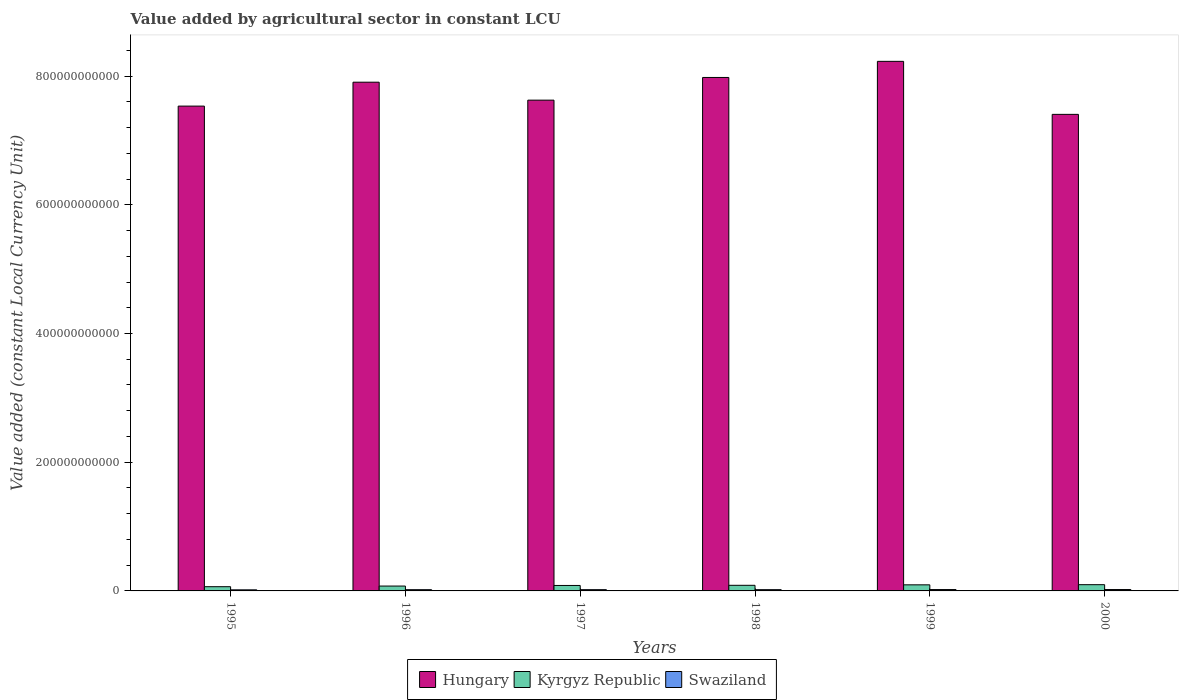How many different coloured bars are there?
Give a very brief answer. 3. How many groups of bars are there?
Ensure brevity in your answer.  6. Are the number of bars per tick equal to the number of legend labels?
Your answer should be compact. Yes. Are the number of bars on each tick of the X-axis equal?
Give a very brief answer. Yes. How many bars are there on the 6th tick from the left?
Your response must be concise. 3. What is the label of the 3rd group of bars from the left?
Offer a very short reply. 1997. In how many cases, is the number of bars for a given year not equal to the number of legend labels?
Your answer should be very brief. 0. What is the value added by agricultural sector in Swaziland in 1997?
Offer a very short reply. 1.96e+09. Across all years, what is the maximum value added by agricultural sector in Hungary?
Provide a succinct answer. 8.23e+11. Across all years, what is the minimum value added by agricultural sector in Hungary?
Keep it short and to the point. 7.41e+11. In which year was the value added by agricultural sector in Hungary minimum?
Offer a very short reply. 2000. What is the total value added by agricultural sector in Swaziland in the graph?
Your response must be concise. 1.18e+1. What is the difference between the value added by agricultural sector in Hungary in 1995 and that in 1998?
Offer a very short reply. -4.45e+1. What is the difference between the value added by agricultural sector in Kyrgyz Republic in 1997 and the value added by agricultural sector in Hungary in 1995?
Provide a succinct answer. -7.45e+11. What is the average value added by agricultural sector in Swaziland per year?
Ensure brevity in your answer.  1.97e+09. In the year 1997, what is the difference between the value added by agricultural sector in Kyrgyz Republic and value added by agricultural sector in Swaziland?
Provide a succinct answer. 6.53e+09. What is the ratio of the value added by agricultural sector in Swaziland in 1995 to that in 1997?
Offer a very short reply. 0.86. Is the value added by agricultural sector in Swaziland in 1995 less than that in 1996?
Provide a short and direct response. Yes. Is the difference between the value added by agricultural sector in Kyrgyz Republic in 1995 and 1996 greater than the difference between the value added by agricultural sector in Swaziland in 1995 and 1996?
Provide a succinct answer. No. What is the difference between the highest and the second highest value added by agricultural sector in Kyrgyz Republic?
Provide a short and direct response. 2.53e+08. What is the difference between the highest and the lowest value added by agricultural sector in Kyrgyz Republic?
Give a very brief answer. 3.14e+09. Is the sum of the value added by agricultural sector in Hungary in 1996 and 1998 greater than the maximum value added by agricultural sector in Swaziland across all years?
Your answer should be compact. Yes. What does the 1st bar from the left in 1999 represents?
Make the answer very short. Hungary. What does the 3rd bar from the right in 1999 represents?
Keep it short and to the point. Hungary. Is it the case that in every year, the sum of the value added by agricultural sector in Hungary and value added by agricultural sector in Swaziland is greater than the value added by agricultural sector in Kyrgyz Republic?
Keep it short and to the point. Yes. How many bars are there?
Ensure brevity in your answer.  18. How many years are there in the graph?
Your answer should be compact. 6. What is the difference between two consecutive major ticks on the Y-axis?
Give a very brief answer. 2.00e+11. Does the graph contain grids?
Provide a succinct answer. No. Where does the legend appear in the graph?
Provide a succinct answer. Bottom center. How are the legend labels stacked?
Give a very brief answer. Horizontal. What is the title of the graph?
Provide a short and direct response. Value added by agricultural sector in constant LCU. What is the label or title of the Y-axis?
Make the answer very short. Value added (constant Local Currency Unit). What is the Value added (constant Local Currency Unit) of Hungary in 1995?
Your response must be concise. 7.53e+11. What is the Value added (constant Local Currency Unit) of Kyrgyz Republic in 1995?
Ensure brevity in your answer.  6.57e+09. What is the Value added (constant Local Currency Unit) in Swaziland in 1995?
Offer a terse response. 1.69e+09. What is the Value added (constant Local Currency Unit) in Hungary in 1996?
Keep it short and to the point. 7.91e+11. What is the Value added (constant Local Currency Unit) in Kyrgyz Republic in 1996?
Your answer should be compact. 7.57e+09. What is the Value added (constant Local Currency Unit) of Swaziland in 1996?
Provide a succinct answer. 1.93e+09. What is the Value added (constant Local Currency Unit) of Hungary in 1997?
Ensure brevity in your answer.  7.63e+11. What is the Value added (constant Local Currency Unit) in Kyrgyz Republic in 1997?
Your answer should be very brief. 8.49e+09. What is the Value added (constant Local Currency Unit) of Swaziland in 1997?
Ensure brevity in your answer.  1.96e+09. What is the Value added (constant Local Currency Unit) of Hungary in 1998?
Provide a short and direct response. 7.98e+11. What is the Value added (constant Local Currency Unit) of Kyrgyz Republic in 1998?
Provide a succinct answer. 8.74e+09. What is the Value added (constant Local Currency Unit) of Swaziland in 1998?
Offer a very short reply. 1.96e+09. What is the Value added (constant Local Currency Unit) in Hungary in 1999?
Your answer should be very brief. 8.23e+11. What is the Value added (constant Local Currency Unit) in Kyrgyz Republic in 1999?
Keep it short and to the point. 9.45e+09. What is the Value added (constant Local Currency Unit) of Swaziland in 1999?
Keep it short and to the point. 2.13e+09. What is the Value added (constant Local Currency Unit) in Hungary in 2000?
Your response must be concise. 7.41e+11. What is the Value added (constant Local Currency Unit) of Kyrgyz Republic in 2000?
Provide a short and direct response. 9.71e+09. What is the Value added (constant Local Currency Unit) of Swaziland in 2000?
Keep it short and to the point. 2.15e+09. Across all years, what is the maximum Value added (constant Local Currency Unit) in Hungary?
Ensure brevity in your answer.  8.23e+11. Across all years, what is the maximum Value added (constant Local Currency Unit) of Kyrgyz Republic?
Make the answer very short. 9.71e+09. Across all years, what is the maximum Value added (constant Local Currency Unit) in Swaziland?
Offer a terse response. 2.15e+09. Across all years, what is the minimum Value added (constant Local Currency Unit) in Hungary?
Your response must be concise. 7.41e+11. Across all years, what is the minimum Value added (constant Local Currency Unit) of Kyrgyz Republic?
Your response must be concise. 6.57e+09. Across all years, what is the minimum Value added (constant Local Currency Unit) of Swaziland?
Ensure brevity in your answer.  1.69e+09. What is the total Value added (constant Local Currency Unit) in Hungary in the graph?
Provide a short and direct response. 4.67e+12. What is the total Value added (constant Local Currency Unit) of Kyrgyz Republic in the graph?
Your response must be concise. 5.05e+1. What is the total Value added (constant Local Currency Unit) of Swaziland in the graph?
Offer a terse response. 1.18e+1. What is the difference between the Value added (constant Local Currency Unit) in Hungary in 1995 and that in 1996?
Offer a very short reply. -3.72e+1. What is the difference between the Value added (constant Local Currency Unit) in Kyrgyz Republic in 1995 and that in 1996?
Your response must be concise. -9.98e+08. What is the difference between the Value added (constant Local Currency Unit) of Swaziland in 1995 and that in 1996?
Make the answer very short. -2.33e+08. What is the difference between the Value added (constant Local Currency Unit) in Hungary in 1995 and that in 1997?
Ensure brevity in your answer.  -9.25e+09. What is the difference between the Value added (constant Local Currency Unit) in Kyrgyz Republic in 1995 and that in 1997?
Make the answer very short. -1.93e+09. What is the difference between the Value added (constant Local Currency Unit) in Swaziland in 1995 and that in 1997?
Your answer should be compact. -2.69e+08. What is the difference between the Value added (constant Local Currency Unit) in Hungary in 1995 and that in 1998?
Keep it short and to the point. -4.45e+1. What is the difference between the Value added (constant Local Currency Unit) of Kyrgyz Republic in 1995 and that in 1998?
Give a very brief answer. -2.17e+09. What is the difference between the Value added (constant Local Currency Unit) of Swaziland in 1995 and that in 1998?
Offer a very short reply. -2.66e+08. What is the difference between the Value added (constant Local Currency Unit) of Hungary in 1995 and that in 1999?
Your response must be concise. -6.95e+1. What is the difference between the Value added (constant Local Currency Unit) of Kyrgyz Republic in 1995 and that in 1999?
Ensure brevity in your answer.  -2.88e+09. What is the difference between the Value added (constant Local Currency Unit) of Swaziland in 1995 and that in 1999?
Your answer should be compact. -4.38e+08. What is the difference between the Value added (constant Local Currency Unit) of Hungary in 1995 and that in 2000?
Your answer should be very brief. 1.28e+1. What is the difference between the Value added (constant Local Currency Unit) of Kyrgyz Republic in 1995 and that in 2000?
Ensure brevity in your answer.  -3.14e+09. What is the difference between the Value added (constant Local Currency Unit) of Swaziland in 1995 and that in 2000?
Your response must be concise. -4.54e+08. What is the difference between the Value added (constant Local Currency Unit) in Hungary in 1996 and that in 1997?
Your response must be concise. 2.79e+1. What is the difference between the Value added (constant Local Currency Unit) in Kyrgyz Republic in 1996 and that in 1997?
Your response must be concise. -9.27e+08. What is the difference between the Value added (constant Local Currency Unit) of Swaziland in 1996 and that in 1997?
Offer a very short reply. -3.54e+07. What is the difference between the Value added (constant Local Currency Unit) of Hungary in 1996 and that in 1998?
Your answer should be very brief. -7.34e+09. What is the difference between the Value added (constant Local Currency Unit) of Kyrgyz Republic in 1996 and that in 1998?
Provide a short and direct response. -1.17e+09. What is the difference between the Value added (constant Local Currency Unit) in Swaziland in 1996 and that in 1998?
Your answer should be compact. -3.24e+07. What is the difference between the Value added (constant Local Currency Unit) of Hungary in 1996 and that in 1999?
Give a very brief answer. -3.24e+1. What is the difference between the Value added (constant Local Currency Unit) of Kyrgyz Republic in 1996 and that in 1999?
Offer a terse response. -1.89e+09. What is the difference between the Value added (constant Local Currency Unit) of Swaziland in 1996 and that in 1999?
Your response must be concise. -2.04e+08. What is the difference between the Value added (constant Local Currency Unit) in Hungary in 1996 and that in 2000?
Give a very brief answer. 5.00e+1. What is the difference between the Value added (constant Local Currency Unit) of Kyrgyz Republic in 1996 and that in 2000?
Ensure brevity in your answer.  -2.14e+09. What is the difference between the Value added (constant Local Currency Unit) in Swaziland in 1996 and that in 2000?
Offer a terse response. -2.21e+08. What is the difference between the Value added (constant Local Currency Unit) of Hungary in 1997 and that in 1998?
Give a very brief answer. -3.53e+1. What is the difference between the Value added (constant Local Currency Unit) in Kyrgyz Republic in 1997 and that in 1998?
Provide a short and direct response. -2.42e+08. What is the difference between the Value added (constant Local Currency Unit) in Swaziland in 1997 and that in 1998?
Offer a terse response. 3.04e+06. What is the difference between the Value added (constant Local Currency Unit) of Hungary in 1997 and that in 1999?
Offer a very short reply. -6.03e+1. What is the difference between the Value added (constant Local Currency Unit) in Kyrgyz Republic in 1997 and that in 1999?
Offer a very short reply. -9.60e+08. What is the difference between the Value added (constant Local Currency Unit) of Swaziland in 1997 and that in 1999?
Ensure brevity in your answer.  -1.69e+08. What is the difference between the Value added (constant Local Currency Unit) of Hungary in 1997 and that in 2000?
Provide a succinct answer. 2.21e+1. What is the difference between the Value added (constant Local Currency Unit) of Kyrgyz Republic in 1997 and that in 2000?
Your answer should be very brief. -1.21e+09. What is the difference between the Value added (constant Local Currency Unit) of Swaziland in 1997 and that in 2000?
Offer a terse response. -1.85e+08. What is the difference between the Value added (constant Local Currency Unit) in Hungary in 1998 and that in 1999?
Keep it short and to the point. -2.50e+1. What is the difference between the Value added (constant Local Currency Unit) in Kyrgyz Republic in 1998 and that in 1999?
Make the answer very short. -7.17e+08. What is the difference between the Value added (constant Local Currency Unit) in Swaziland in 1998 and that in 1999?
Give a very brief answer. -1.72e+08. What is the difference between the Value added (constant Local Currency Unit) of Hungary in 1998 and that in 2000?
Ensure brevity in your answer.  5.74e+1. What is the difference between the Value added (constant Local Currency Unit) in Kyrgyz Republic in 1998 and that in 2000?
Provide a succinct answer. -9.71e+08. What is the difference between the Value added (constant Local Currency Unit) of Swaziland in 1998 and that in 2000?
Offer a terse response. -1.89e+08. What is the difference between the Value added (constant Local Currency Unit) of Hungary in 1999 and that in 2000?
Your response must be concise. 8.24e+1. What is the difference between the Value added (constant Local Currency Unit) in Kyrgyz Republic in 1999 and that in 2000?
Offer a terse response. -2.53e+08. What is the difference between the Value added (constant Local Currency Unit) of Swaziland in 1999 and that in 2000?
Ensure brevity in your answer.  -1.66e+07. What is the difference between the Value added (constant Local Currency Unit) in Hungary in 1995 and the Value added (constant Local Currency Unit) in Kyrgyz Republic in 1996?
Your response must be concise. 7.46e+11. What is the difference between the Value added (constant Local Currency Unit) in Hungary in 1995 and the Value added (constant Local Currency Unit) in Swaziland in 1996?
Ensure brevity in your answer.  7.51e+11. What is the difference between the Value added (constant Local Currency Unit) of Kyrgyz Republic in 1995 and the Value added (constant Local Currency Unit) of Swaziland in 1996?
Ensure brevity in your answer.  4.64e+09. What is the difference between the Value added (constant Local Currency Unit) of Hungary in 1995 and the Value added (constant Local Currency Unit) of Kyrgyz Republic in 1997?
Offer a very short reply. 7.45e+11. What is the difference between the Value added (constant Local Currency Unit) in Hungary in 1995 and the Value added (constant Local Currency Unit) in Swaziland in 1997?
Make the answer very short. 7.51e+11. What is the difference between the Value added (constant Local Currency Unit) in Kyrgyz Republic in 1995 and the Value added (constant Local Currency Unit) in Swaziland in 1997?
Give a very brief answer. 4.61e+09. What is the difference between the Value added (constant Local Currency Unit) of Hungary in 1995 and the Value added (constant Local Currency Unit) of Kyrgyz Republic in 1998?
Ensure brevity in your answer.  7.45e+11. What is the difference between the Value added (constant Local Currency Unit) of Hungary in 1995 and the Value added (constant Local Currency Unit) of Swaziland in 1998?
Offer a very short reply. 7.51e+11. What is the difference between the Value added (constant Local Currency Unit) in Kyrgyz Republic in 1995 and the Value added (constant Local Currency Unit) in Swaziland in 1998?
Provide a succinct answer. 4.61e+09. What is the difference between the Value added (constant Local Currency Unit) of Hungary in 1995 and the Value added (constant Local Currency Unit) of Kyrgyz Republic in 1999?
Provide a short and direct response. 7.44e+11. What is the difference between the Value added (constant Local Currency Unit) in Hungary in 1995 and the Value added (constant Local Currency Unit) in Swaziland in 1999?
Your answer should be compact. 7.51e+11. What is the difference between the Value added (constant Local Currency Unit) of Kyrgyz Republic in 1995 and the Value added (constant Local Currency Unit) of Swaziland in 1999?
Provide a short and direct response. 4.44e+09. What is the difference between the Value added (constant Local Currency Unit) in Hungary in 1995 and the Value added (constant Local Currency Unit) in Kyrgyz Republic in 2000?
Ensure brevity in your answer.  7.44e+11. What is the difference between the Value added (constant Local Currency Unit) in Hungary in 1995 and the Value added (constant Local Currency Unit) in Swaziland in 2000?
Offer a very short reply. 7.51e+11. What is the difference between the Value added (constant Local Currency Unit) of Kyrgyz Republic in 1995 and the Value added (constant Local Currency Unit) of Swaziland in 2000?
Provide a succinct answer. 4.42e+09. What is the difference between the Value added (constant Local Currency Unit) in Hungary in 1996 and the Value added (constant Local Currency Unit) in Kyrgyz Republic in 1997?
Offer a very short reply. 7.82e+11. What is the difference between the Value added (constant Local Currency Unit) of Hungary in 1996 and the Value added (constant Local Currency Unit) of Swaziland in 1997?
Keep it short and to the point. 7.89e+11. What is the difference between the Value added (constant Local Currency Unit) of Kyrgyz Republic in 1996 and the Value added (constant Local Currency Unit) of Swaziland in 1997?
Keep it short and to the point. 5.60e+09. What is the difference between the Value added (constant Local Currency Unit) of Hungary in 1996 and the Value added (constant Local Currency Unit) of Kyrgyz Republic in 1998?
Your answer should be very brief. 7.82e+11. What is the difference between the Value added (constant Local Currency Unit) in Hungary in 1996 and the Value added (constant Local Currency Unit) in Swaziland in 1998?
Your answer should be very brief. 7.89e+11. What is the difference between the Value added (constant Local Currency Unit) in Kyrgyz Republic in 1996 and the Value added (constant Local Currency Unit) in Swaziland in 1998?
Make the answer very short. 5.61e+09. What is the difference between the Value added (constant Local Currency Unit) in Hungary in 1996 and the Value added (constant Local Currency Unit) in Kyrgyz Republic in 1999?
Provide a short and direct response. 7.81e+11. What is the difference between the Value added (constant Local Currency Unit) of Hungary in 1996 and the Value added (constant Local Currency Unit) of Swaziland in 1999?
Make the answer very short. 7.88e+11. What is the difference between the Value added (constant Local Currency Unit) of Kyrgyz Republic in 1996 and the Value added (constant Local Currency Unit) of Swaziland in 1999?
Your response must be concise. 5.44e+09. What is the difference between the Value added (constant Local Currency Unit) of Hungary in 1996 and the Value added (constant Local Currency Unit) of Kyrgyz Republic in 2000?
Your answer should be very brief. 7.81e+11. What is the difference between the Value added (constant Local Currency Unit) in Hungary in 1996 and the Value added (constant Local Currency Unit) in Swaziland in 2000?
Provide a short and direct response. 7.88e+11. What is the difference between the Value added (constant Local Currency Unit) of Kyrgyz Republic in 1996 and the Value added (constant Local Currency Unit) of Swaziland in 2000?
Provide a succinct answer. 5.42e+09. What is the difference between the Value added (constant Local Currency Unit) of Hungary in 1997 and the Value added (constant Local Currency Unit) of Kyrgyz Republic in 1998?
Your answer should be compact. 7.54e+11. What is the difference between the Value added (constant Local Currency Unit) in Hungary in 1997 and the Value added (constant Local Currency Unit) in Swaziland in 1998?
Ensure brevity in your answer.  7.61e+11. What is the difference between the Value added (constant Local Currency Unit) in Kyrgyz Republic in 1997 and the Value added (constant Local Currency Unit) in Swaziland in 1998?
Offer a very short reply. 6.54e+09. What is the difference between the Value added (constant Local Currency Unit) in Hungary in 1997 and the Value added (constant Local Currency Unit) in Kyrgyz Republic in 1999?
Your answer should be compact. 7.53e+11. What is the difference between the Value added (constant Local Currency Unit) of Hungary in 1997 and the Value added (constant Local Currency Unit) of Swaziland in 1999?
Give a very brief answer. 7.60e+11. What is the difference between the Value added (constant Local Currency Unit) in Kyrgyz Republic in 1997 and the Value added (constant Local Currency Unit) in Swaziland in 1999?
Offer a terse response. 6.36e+09. What is the difference between the Value added (constant Local Currency Unit) in Hungary in 1997 and the Value added (constant Local Currency Unit) in Kyrgyz Republic in 2000?
Your answer should be very brief. 7.53e+11. What is the difference between the Value added (constant Local Currency Unit) of Hungary in 1997 and the Value added (constant Local Currency Unit) of Swaziland in 2000?
Keep it short and to the point. 7.60e+11. What is the difference between the Value added (constant Local Currency Unit) of Kyrgyz Republic in 1997 and the Value added (constant Local Currency Unit) of Swaziland in 2000?
Offer a very short reply. 6.35e+09. What is the difference between the Value added (constant Local Currency Unit) of Hungary in 1998 and the Value added (constant Local Currency Unit) of Kyrgyz Republic in 1999?
Provide a succinct answer. 7.88e+11. What is the difference between the Value added (constant Local Currency Unit) in Hungary in 1998 and the Value added (constant Local Currency Unit) in Swaziland in 1999?
Your answer should be compact. 7.96e+11. What is the difference between the Value added (constant Local Currency Unit) of Kyrgyz Republic in 1998 and the Value added (constant Local Currency Unit) of Swaziland in 1999?
Your answer should be compact. 6.61e+09. What is the difference between the Value added (constant Local Currency Unit) of Hungary in 1998 and the Value added (constant Local Currency Unit) of Kyrgyz Republic in 2000?
Ensure brevity in your answer.  7.88e+11. What is the difference between the Value added (constant Local Currency Unit) in Hungary in 1998 and the Value added (constant Local Currency Unit) in Swaziland in 2000?
Make the answer very short. 7.96e+11. What is the difference between the Value added (constant Local Currency Unit) of Kyrgyz Republic in 1998 and the Value added (constant Local Currency Unit) of Swaziland in 2000?
Offer a very short reply. 6.59e+09. What is the difference between the Value added (constant Local Currency Unit) of Hungary in 1999 and the Value added (constant Local Currency Unit) of Kyrgyz Republic in 2000?
Provide a short and direct response. 8.13e+11. What is the difference between the Value added (constant Local Currency Unit) in Hungary in 1999 and the Value added (constant Local Currency Unit) in Swaziland in 2000?
Your answer should be compact. 8.21e+11. What is the difference between the Value added (constant Local Currency Unit) in Kyrgyz Republic in 1999 and the Value added (constant Local Currency Unit) in Swaziland in 2000?
Offer a terse response. 7.31e+09. What is the average Value added (constant Local Currency Unit) of Hungary per year?
Give a very brief answer. 7.78e+11. What is the average Value added (constant Local Currency Unit) in Kyrgyz Republic per year?
Provide a succinct answer. 8.42e+09. What is the average Value added (constant Local Currency Unit) in Swaziland per year?
Offer a terse response. 1.97e+09. In the year 1995, what is the difference between the Value added (constant Local Currency Unit) in Hungary and Value added (constant Local Currency Unit) in Kyrgyz Republic?
Your response must be concise. 7.47e+11. In the year 1995, what is the difference between the Value added (constant Local Currency Unit) in Hungary and Value added (constant Local Currency Unit) in Swaziland?
Make the answer very short. 7.52e+11. In the year 1995, what is the difference between the Value added (constant Local Currency Unit) of Kyrgyz Republic and Value added (constant Local Currency Unit) of Swaziland?
Your response must be concise. 4.88e+09. In the year 1996, what is the difference between the Value added (constant Local Currency Unit) of Hungary and Value added (constant Local Currency Unit) of Kyrgyz Republic?
Your response must be concise. 7.83e+11. In the year 1996, what is the difference between the Value added (constant Local Currency Unit) of Hungary and Value added (constant Local Currency Unit) of Swaziland?
Offer a terse response. 7.89e+11. In the year 1996, what is the difference between the Value added (constant Local Currency Unit) in Kyrgyz Republic and Value added (constant Local Currency Unit) in Swaziland?
Make the answer very short. 5.64e+09. In the year 1997, what is the difference between the Value added (constant Local Currency Unit) of Hungary and Value added (constant Local Currency Unit) of Kyrgyz Republic?
Your answer should be compact. 7.54e+11. In the year 1997, what is the difference between the Value added (constant Local Currency Unit) in Hungary and Value added (constant Local Currency Unit) in Swaziland?
Provide a succinct answer. 7.61e+11. In the year 1997, what is the difference between the Value added (constant Local Currency Unit) of Kyrgyz Republic and Value added (constant Local Currency Unit) of Swaziland?
Offer a very short reply. 6.53e+09. In the year 1998, what is the difference between the Value added (constant Local Currency Unit) of Hungary and Value added (constant Local Currency Unit) of Kyrgyz Republic?
Offer a very short reply. 7.89e+11. In the year 1998, what is the difference between the Value added (constant Local Currency Unit) in Hungary and Value added (constant Local Currency Unit) in Swaziland?
Provide a short and direct response. 7.96e+11. In the year 1998, what is the difference between the Value added (constant Local Currency Unit) of Kyrgyz Republic and Value added (constant Local Currency Unit) of Swaziland?
Offer a very short reply. 6.78e+09. In the year 1999, what is the difference between the Value added (constant Local Currency Unit) of Hungary and Value added (constant Local Currency Unit) of Kyrgyz Republic?
Your answer should be compact. 8.13e+11. In the year 1999, what is the difference between the Value added (constant Local Currency Unit) in Hungary and Value added (constant Local Currency Unit) in Swaziland?
Give a very brief answer. 8.21e+11. In the year 1999, what is the difference between the Value added (constant Local Currency Unit) in Kyrgyz Republic and Value added (constant Local Currency Unit) in Swaziland?
Keep it short and to the point. 7.32e+09. In the year 2000, what is the difference between the Value added (constant Local Currency Unit) in Hungary and Value added (constant Local Currency Unit) in Kyrgyz Republic?
Keep it short and to the point. 7.31e+11. In the year 2000, what is the difference between the Value added (constant Local Currency Unit) in Hungary and Value added (constant Local Currency Unit) in Swaziland?
Your answer should be compact. 7.38e+11. In the year 2000, what is the difference between the Value added (constant Local Currency Unit) of Kyrgyz Republic and Value added (constant Local Currency Unit) of Swaziland?
Your response must be concise. 7.56e+09. What is the ratio of the Value added (constant Local Currency Unit) of Hungary in 1995 to that in 1996?
Provide a succinct answer. 0.95. What is the ratio of the Value added (constant Local Currency Unit) in Kyrgyz Republic in 1995 to that in 1996?
Offer a very short reply. 0.87. What is the ratio of the Value added (constant Local Currency Unit) in Swaziland in 1995 to that in 1996?
Your answer should be very brief. 0.88. What is the ratio of the Value added (constant Local Currency Unit) of Hungary in 1995 to that in 1997?
Your response must be concise. 0.99. What is the ratio of the Value added (constant Local Currency Unit) of Kyrgyz Republic in 1995 to that in 1997?
Your response must be concise. 0.77. What is the ratio of the Value added (constant Local Currency Unit) of Swaziland in 1995 to that in 1997?
Offer a terse response. 0.86. What is the ratio of the Value added (constant Local Currency Unit) of Hungary in 1995 to that in 1998?
Offer a very short reply. 0.94. What is the ratio of the Value added (constant Local Currency Unit) in Kyrgyz Republic in 1995 to that in 1998?
Your answer should be very brief. 0.75. What is the ratio of the Value added (constant Local Currency Unit) in Swaziland in 1995 to that in 1998?
Give a very brief answer. 0.86. What is the ratio of the Value added (constant Local Currency Unit) in Hungary in 1995 to that in 1999?
Ensure brevity in your answer.  0.92. What is the ratio of the Value added (constant Local Currency Unit) in Kyrgyz Republic in 1995 to that in 1999?
Your answer should be very brief. 0.69. What is the ratio of the Value added (constant Local Currency Unit) in Swaziland in 1995 to that in 1999?
Provide a short and direct response. 0.79. What is the ratio of the Value added (constant Local Currency Unit) in Hungary in 1995 to that in 2000?
Keep it short and to the point. 1.02. What is the ratio of the Value added (constant Local Currency Unit) of Kyrgyz Republic in 1995 to that in 2000?
Offer a very short reply. 0.68. What is the ratio of the Value added (constant Local Currency Unit) of Swaziland in 1995 to that in 2000?
Provide a succinct answer. 0.79. What is the ratio of the Value added (constant Local Currency Unit) of Hungary in 1996 to that in 1997?
Your answer should be very brief. 1.04. What is the ratio of the Value added (constant Local Currency Unit) in Kyrgyz Republic in 1996 to that in 1997?
Keep it short and to the point. 0.89. What is the ratio of the Value added (constant Local Currency Unit) of Swaziland in 1996 to that in 1997?
Provide a short and direct response. 0.98. What is the ratio of the Value added (constant Local Currency Unit) in Hungary in 1996 to that in 1998?
Provide a short and direct response. 0.99. What is the ratio of the Value added (constant Local Currency Unit) of Kyrgyz Republic in 1996 to that in 1998?
Your answer should be compact. 0.87. What is the ratio of the Value added (constant Local Currency Unit) in Swaziland in 1996 to that in 1998?
Give a very brief answer. 0.98. What is the ratio of the Value added (constant Local Currency Unit) in Hungary in 1996 to that in 1999?
Offer a very short reply. 0.96. What is the ratio of the Value added (constant Local Currency Unit) in Kyrgyz Republic in 1996 to that in 1999?
Offer a terse response. 0.8. What is the ratio of the Value added (constant Local Currency Unit) of Swaziland in 1996 to that in 1999?
Provide a succinct answer. 0.9. What is the ratio of the Value added (constant Local Currency Unit) in Hungary in 1996 to that in 2000?
Your answer should be very brief. 1.07. What is the ratio of the Value added (constant Local Currency Unit) in Kyrgyz Republic in 1996 to that in 2000?
Offer a very short reply. 0.78. What is the ratio of the Value added (constant Local Currency Unit) of Swaziland in 1996 to that in 2000?
Your response must be concise. 0.9. What is the ratio of the Value added (constant Local Currency Unit) of Hungary in 1997 to that in 1998?
Offer a very short reply. 0.96. What is the ratio of the Value added (constant Local Currency Unit) in Kyrgyz Republic in 1997 to that in 1998?
Offer a terse response. 0.97. What is the ratio of the Value added (constant Local Currency Unit) of Swaziland in 1997 to that in 1998?
Ensure brevity in your answer.  1. What is the ratio of the Value added (constant Local Currency Unit) in Hungary in 1997 to that in 1999?
Your answer should be compact. 0.93. What is the ratio of the Value added (constant Local Currency Unit) of Kyrgyz Republic in 1997 to that in 1999?
Your answer should be compact. 0.9. What is the ratio of the Value added (constant Local Currency Unit) in Swaziland in 1997 to that in 1999?
Your answer should be compact. 0.92. What is the ratio of the Value added (constant Local Currency Unit) in Hungary in 1997 to that in 2000?
Keep it short and to the point. 1.03. What is the ratio of the Value added (constant Local Currency Unit) in Swaziland in 1997 to that in 2000?
Your answer should be very brief. 0.91. What is the ratio of the Value added (constant Local Currency Unit) in Hungary in 1998 to that in 1999?
Your response must be concise. 0.97. What is the ratio of the Value added (constant Local Currency Unit) in Kyrgyz Republic in 1998 to that in 1999?
Offer a terse response. 0.92. What is the ratio of the Value added (constant Local Currency Unit) in Swaziland in 1998 to that in 1999?
Keep it short and to the point. 0.92. What is the ratio of the Value added (constant Local Currency Unit) in Hungary in 1998 to that in 2000?
Your answer should be very brief. 1.08. What is the ratio of the Value added (constant Local Currency Unit) in Swaziland in 1998 to that in 2000?
Your answer should be very brief. 0.91. What is the ratio of the Value added (constant Local Currency Unit) in Hungary in 1999 to that in 2000?
Keep it short and to the point. 1.11. What is the ratio of the Value added (constant Local Currency Unit) in Kyrgyz Republic in 1999 to that in 2000?
Offer a terse response. 0.97. What is the difference between the highest and the second highest Value added (constant Local Currency Unit) in Hungary?
Give a very brief answer. 2.50e+1. What is the difference between the highest and the second highest Value added (constant Local Currency Unit) in Kyrgyz Republic?
Your response must be concise. 2.53e+08. What is the difference between the highest and the second highest Value added (constant Local Currency Unit) in Swaziland?
Make the answer very short. 1.66e+07. What is the difference between the highest and the lowest Value added (constant Local Currency Unit) of Hungary?
Keep it short and to the point. 8.24e+1. What is the difference between the highest and the lowest Value added (constant Local Currency Unit) of Kyrgyz Republic?
Provide a succinct answer. 3.14e+09. What is the difference between the highest and the lowest Value added (constant Local Currency Unit) in Swaziland?
Your answer should be compact. 4.54e+08. 